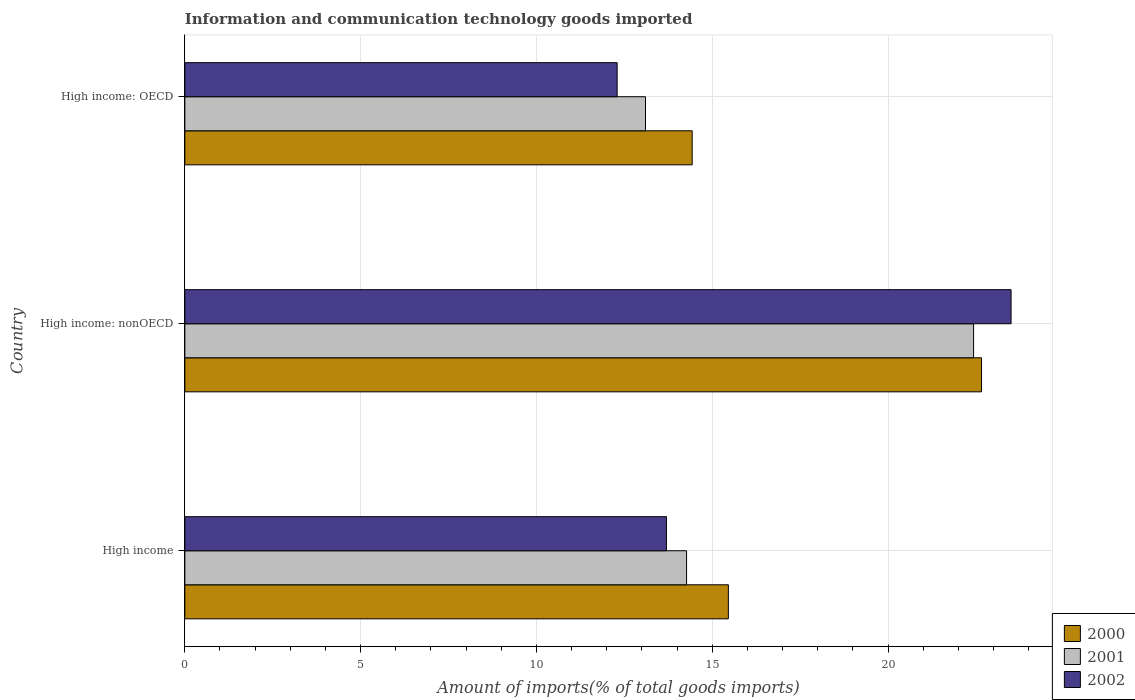Are the number of bars per tick equal to the number of legend labels?
Offer a very short reply. Yes. What is the label of the 1st group of bars from the top?
Your response must be concise. High income: OECD. In how many cases, is the number of bars for a given country not equal to the number of legend labels?
Offer a terse response. 0. What is the amount of goods imported in 2002 in High income: OECD?
Keep it short and to the point. 12.3. Across all countries, what is the maximum amount of goods imported in 2001?
Provide a short and direct response. 22.43. Across all countries, what is the minimum amount of goods imported in 2000?
Offer a terse response. 14.43. In which country was the amount of goods imported in 2000 maximum?
Your answer should be very brief. High income: nonOECD. In which country was the amount of goods imported in 2000 minimum?
Provide a short and direct response. High income: OECD. What is the total amount of goods imported in 2002 in the graph?
Give a very brief answer. 49.49. What is the difference between the amount of goods imported in 2000 in High income and that in High income: nonOECD?
Give a very brief answer. -7.2. What is the difference between the amount of goods imported in 2001 in High income: OECD and the amount of goods imported in 2000 in High income: nonOECD?
Offer a terse response. -9.56. What is the average amount of goods imported in 2002 per country?
Your answer should be compact. 16.5. What is the difference between the amount of goods imported in 2001 and amount of goods imported in 2000 in High income: nonOECD?
Your response must be concise. -0.23. In how many countries, is the amount of goods imported in 2002 greater than 5 %?
Your answer should be compact. 3. What is the ratio of the amount of goods imported in 2001 in High income: OECD to that in High income: nonOECD?
Offer a very short reply. 0.58. What is the difference between the highest and the second highest amount of goods imported in 2000?
Your answer should be compact. 7.2. What is the difference between the highest and the lowest amount of goods imported in 2002?
Offer a very short reply. 11.2. In how many countries, is the amount of goods imported in 2000 greater than the average amount of goods imported in 2000 taken over all countries?
Provide a short and direct response. 1. What does the 3rd bar from the top in High income: OECD represents?
Provide a succinct answer. 2000. How many bars are there?
Provide a succinct answer. 9. How many countries are there in the graph?
Provide a short and direct response. 3. Does the graph contain grids?
Your answer should be very brief. Yes. Where does the legend appear in the graph?
Your response must be concise. Bottom right. How many legend labels are there?
Your answer should be very brief. 3. How are the legend labels stacked?
Ensure brevity in your answer.  Vertical. What is the title of the graph?
Make the answer very short. Information and communication technology goods imported. What is the label or title of the X-axis?
Offer a very short reply. Amount of imports(% of total goods imports). What is the Amount of imports(% of total goods imports) in 2000 in High income?
Give a very brief answer. 15.46. What is the Amount of imports(% of total goods imports) of 2001 in High income?
Give a very brief answer. 14.27. What is the Amount of imports(% of total goods imports) in 2002 in High income?
Offer a terse response. 13.7. What is the Amount of imports(% of total goods imports) of 2000 in High income: nonOECD?
Your response must be concise. 22.66. What is the Amount of imports(% of total goods imports) in 2001 in High income: nonOECD?
Keep it short and to the point. 22.43. What is the Amount of imports(% of total goods imports) of 2002 in High income: nonOECD?
Offer a terse response. 23.5. What is the Amount of imports(% of total goods imports) in 2000 in High income: OECD?
Your response must be concise. 14.43. What is the Amount of imports(% of total goods imports) in 2001 in High income: OECD?
Your answer should be compact. 13.1. What is the Amount of imports(% of total goods imports) of 2002 in High income: OECD?
Give a very brief answer. 12.3. Across all countries, what is the maximum Amount of imports(% of total goods imports) in 2000?
Make the answer very short. 22.66. Across all countries, what is the maximum Amount of imports(% of total goods imports) of 2001?
Keep it short and to the point. 22.43. Across all countries, what is the maximum Amount of imports(% of total goods imports) of 2002?
Make the answer very short. 23.5. Across all countries, what is the minimum Amount of imports(% of total goods imports) of 2000?
Your response must be concise. 14.43. Across all countries, what is the minimum Amount of imports(% of total goods imports) in 2001?
Give a very brief answer. 13.1. Across all countries, what is the minimum Amount of imports(% of total goods imports) of 2002?
Provide a short and direct response. 12.3. What is the total Amount of imports(% of total goods imports) in 2000 in the graph?
Provide a succinct answer. 52.55. What is the total Amount of imports(% of total goods imports) of 2001 in the graph?
Give a very brief answer. 49.8. What is the total Amount of imports(% of total goods imports) of 2002 in the graph?
Keep it short and to the point. 49.49. What is the difference between the Amount of imports(% of total goods imports) of 2000 in High income and that in High income: nonOECD?
Give a very brief answer. -7.2. What is the difference between the Amount of imports(% of total goods imports) in 2001 in High income and that in High income: nonOECD?
Keep it short and to the point. -8.16. What is the difference between the Amount of imports(% of total goods imports) in 2002 in High income and that in High income: nonOECD?
Give a very brief answer. -9.8. What is the difference between the Amount of imports(% of total goods imports) in 2000 in High income and that in High income: OECD?
Make the answer very short. 1.03. What is the difference between the Amount of imports(% of total goods imports) in 2001 in High income and that in High income: OECD?
Offer a very short reply. 1.17. What is the difference between the Amount of imports(% of total goods imports) in 2002 in High income and that in High income: OECD?
Keep it short and to the point. 1.4. What is the difference between the Amount of imports(% of total goods imports) of 2000 in High income: nonOECD and that in High income: OECD?
Ensure brevity in your answer.  8.23. What is the difference between the Amount of imports(% of total goods imports) of 2001 in High income: nonOECD and that in High income: OECD?
Ensure brevity in your answer.  9.33. What is the difference between the Amount of imports(% of total goods imports) in 2002 in High income: nonOECD and that in High income: OECD?
Make the answer very short. 11.2. What is the difference between the Amount of imports(% of total goods imports) of 2000 in High income and the Amount of imports(% of total goods imports) of 2001 in High income: nonOECD?
Your answer should be very brief. -6.97. What is the difference between the Amount of imports(% of total goods imports) of 2000 in High income and the Amount of imports(% of total goods imports) of 2002 in High income: nonOECD?
Give a very brief answer. -8.04. What is the difference between the Amount of imports(% of total goods imports) of 2001 in High income and the Amount of imports(% of total goods imports) of 2002 in High income: nonOECD?
Your answer should be very brief. -9.23. What is the difference between the Amount of imports(% of total goods imports) in 2000 in High income and the Amount of imports(% of total goods imports) in 2001 in High income: OECD?
Give a very brief answer. 2.36. What is the difference between the Amount of imports(% of total goods imports) in 2000 in High income and the Amount of imports(% of total goods imports) in 2002 in High income: OECD?
Offer a terse response. 3.16. What is the difference between the Amount of imports(% of total goods imports) of 2001 in High income and the Amount of imports(% of total goods imports) of 2002 in High income: OECD?
Provide a short and direct response. 1.97. What is the difference between the Amount of imports(% of total goods imports) in 2000 in High income: nonOECD and the Amount of imports(% of total goods imports) in 2001 in High income: OECD?
Your response must be concise. 9.56. What is the difference between the Amount of imports(% of total goods imports) of 2000 in High income: nonOECD and the Amount of imports(% of total goods imports) of 2002 in High income: OECD?
Offer a very short reply. 10.36. What is the difference between the Amount of imports(% of total goods imports) of 2001 in High income: nonOECD and the Amount of imports(% of total goods imports) of 2002 in High income: OECD?
Offer a very short reply. 10.14. What is the average Amount of imports(% of total goods imports) of 2000 per country?
Your response must be concise. 17.52. What is the average Amount of imports(% of total goods imports) in 2001 per country?
Your answer should be very brief. 16.6. What is the average Amount of imports(% of total goods imports) of 2002 per country?
Keep it short and to the point. 16.5. What is the difference between the Amount of imports(% of total goods imports) in 2000 and Amount of imports(% of total goods imports) in 2001 in High income?
Your answer should be very brief. 1.19. What is the difference between the Amount of imports(% of total goods imports) in 2000 and Amount of imports(% of total goods imports) in 2002 in High income?
Offer a very short reply. 1.76. What is the difference between the Amount of imports(% of total goods imports) of 2001 and Amount of imports(% of total goods imports) of 2002 in High income?
Your answer should be very brief. 0.57. What is the difference between the Amount of imports(% of total goods imports) in 2000 and Amount of imports(% of total goods imports) in 2001 in High income: nonOECD?
Provide a short and direct response. 0.23. What is the difference between the Amount of imports(% of total goods imports) in 2000 and Amount of imports(% of total goods imports) in 2002 in High income: nonOECD?
Keep it short and to the point. -0.84. What is the difference between the Amount of imports(% of total goods imports) of 2001 and Amount of imports(% of total goods imports) of 2002 in High income: nonOECD?
Provide a succinct answer. -1.07. What is the difference between the Amount of imports(% of total goods imports) in 2000 and Amount of imports(% of total goods imports) in 2001 in High income: OECD?
Your response must be concise. 1.33. What is the difference between the Amount of imports(% of total goods imports) of 2000 and Amount of imports(% of total goods imports) of 2002 in High income: OECD?
Keep it short and to the point. 2.13. What is the difference between the Amount of imports(% of total goods imports) of 2001 and Amount of imports(% of total goods imports) of 2002 in High income: OECD?
Offer a very short reply. 0.81. What is the ratio of the Amount of imports(% of total goods imports) in 2000 in High income to that in High income: nonOECD?
Offer a terse response. 0.68. What is the ratio of the Amount of imports(% of total goods imports) of 2001 in High income to that in High income: nonOECD?
Offer a very short reply. 0.64. What is the ratio of the Amount of imports(% of total goods imports) in 2002 in High income to that in High income: nonOECD?
Your answer should be very brief. 0.58. What is the ratio of the Amount of imports(% of total goods imports) of 2000 in High income to that in High income: OECD?
Your answer should be compact. 1.07. What is the ratio of the Amount of imports(% of total goods imports) of 2001 in High income to that in High income: OECD?
Offer a very short reply. 1.09. What is the ratio of the Amount of imports(% of total goods imports) of 2002 in High income to that in High income: OECD?
Offer a terse response. 1.11. What is the ratio of the Amount of imports(% of total goods imports) of 2000 in High income: nonOECD to that in High income: OECD?
Give a very brief answer. 1.57. What is the ratio of the Amount of imports(% of total goods imports) in 2001 in High income: nonOECD to that in High income: OECD?
Make the answer very short. 1.71. What is the ratio of the Amount of imports(% of total goods imports) in 2002 in High income: nonOECD to that in High income: OECD?
Keep it short and to the point. 1.91. What is the difference between the highest and the second highest Amount of imports(% of total goods imports) in 2000?
Keep it short and to the point. 7.2. What is the difference between the highest and the second highest Amount of imports(% of total goods imports) in 2001?
Keep it short and to the point. 8.16. What is the difference between the highest and the second highest Amount of imports(% of total goods imports) of 2002?
Provide a short and direct response. 9.8. What is the difference between the highest and the lowest Amount of imports(% of total goods imports) of 2000?
Ensure brevity in your answer.  8.23. What is the difference between the highest and the lowest Amount of imports(% of total goods imports) in 2001?
Provide a short and direct response. 9.33. What is the difference between the highest and the lowest Amount of imports(% of total goods imports) in 2002?
Give a very brief answer. 11.2. 